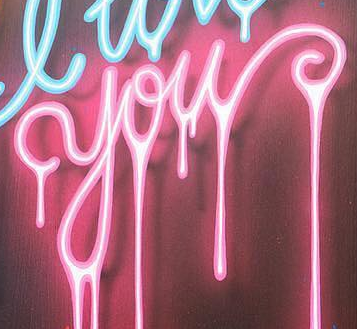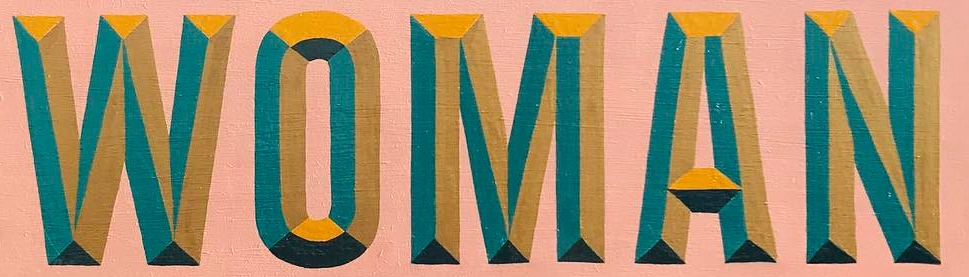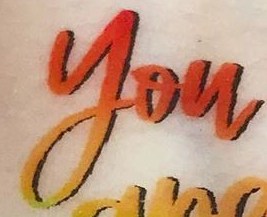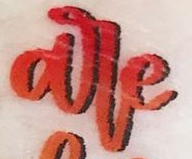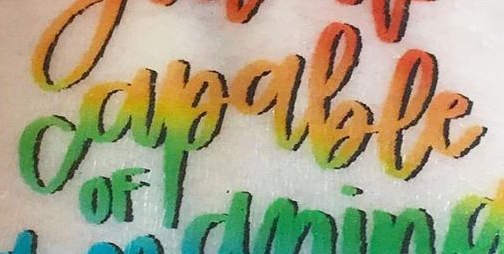What words are shown in these images in order, separated by a semicolon? you; WOMAN; you; are; capable 